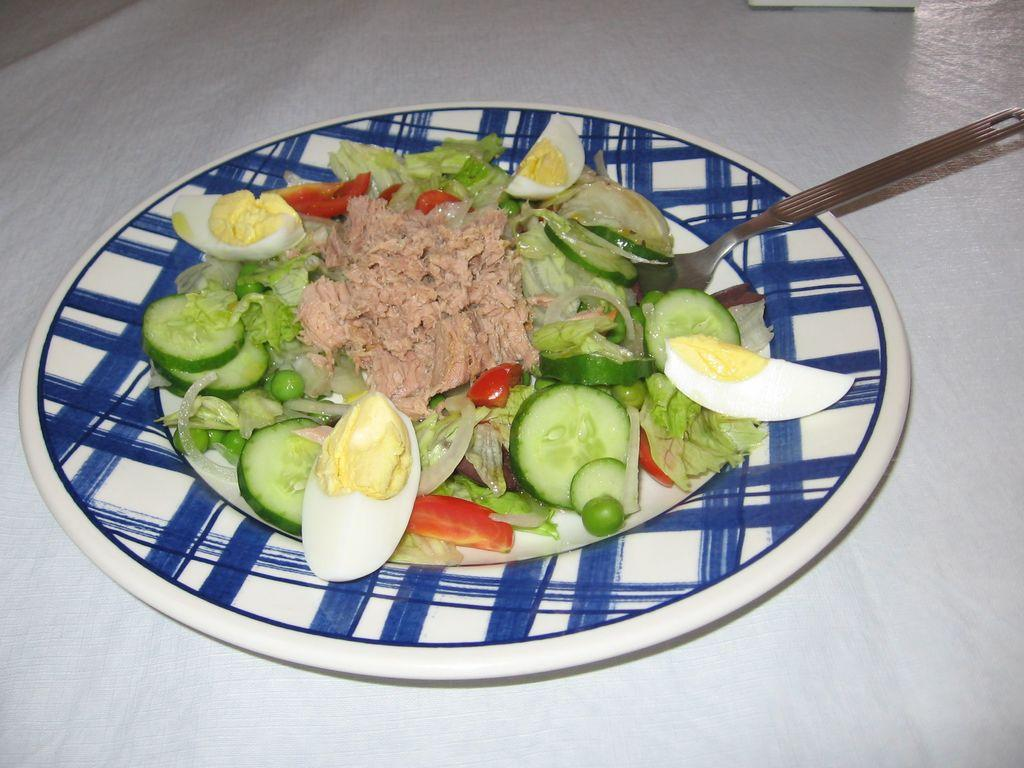What is on the white surface in the image? There is a plate on a white surface. What is on the plate? There is a food item on the plate. What ingredients can be found in the food item? The food item contains pieces of egg, cucumber, tomatoes, and peas. What utensil is present on the plate? There is a fork on the plate. Can you tell me how many companies are represented in the image? There are no companies present in the image; it features a plate with a food item and a fork. Is there a hill visible in the image? There is no hill present in the image; it features a plate with a food item and a fork on a white surface. 